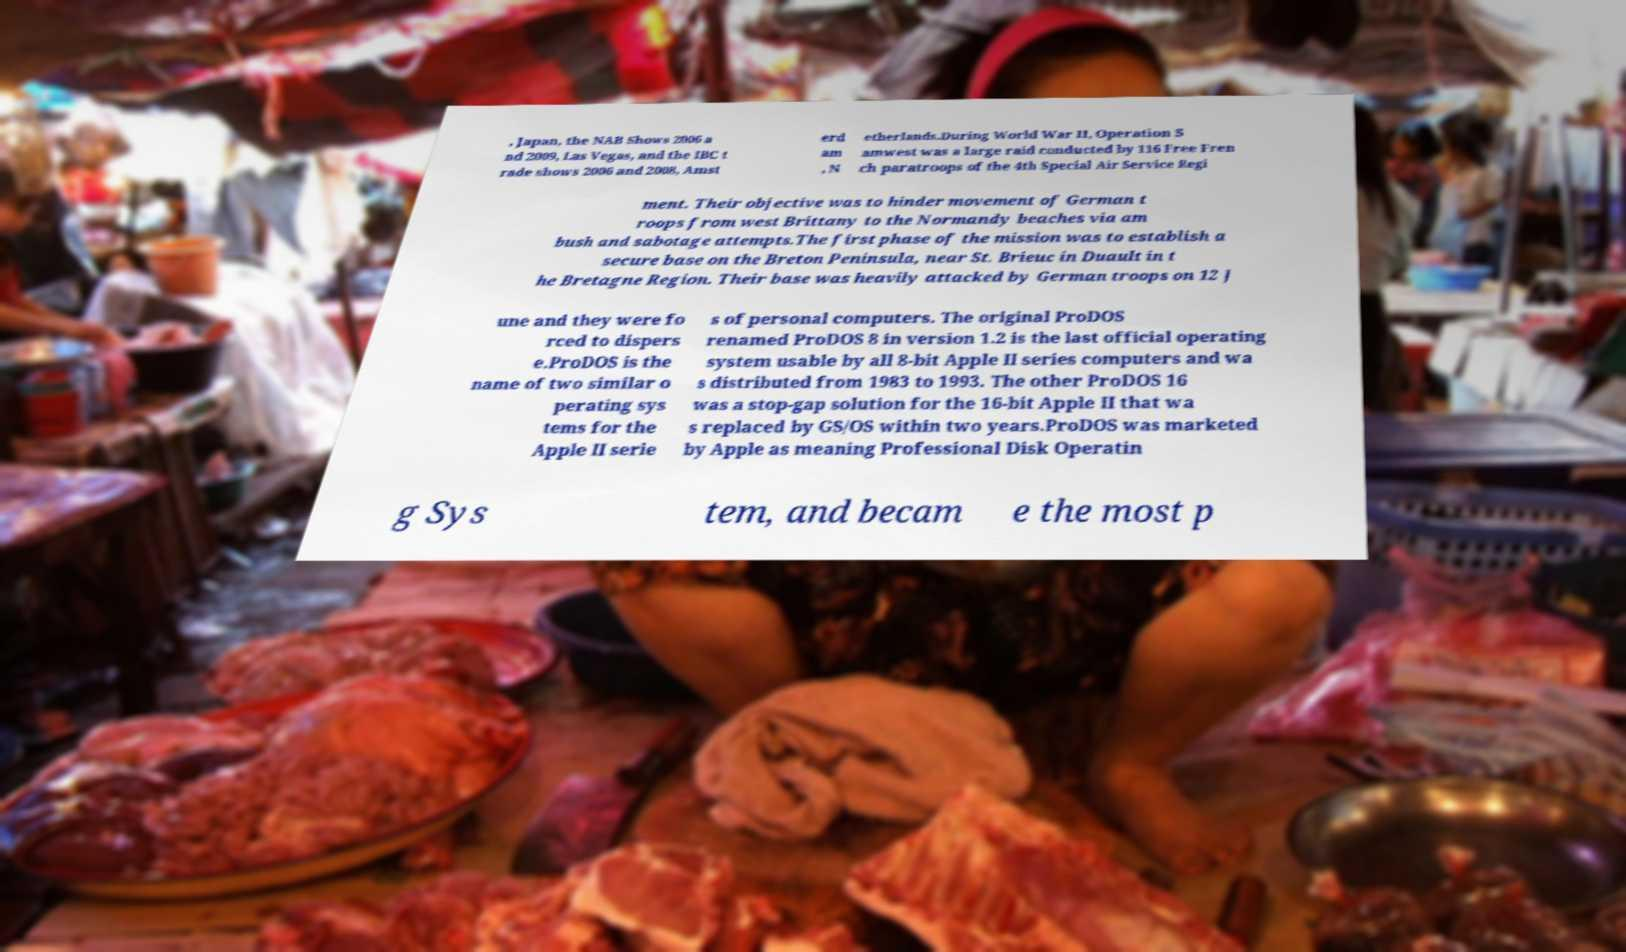I need the written content from this picture converted into text. Can you do that? , Japan, the NAB Shows 2006 a nd 2009, Las Vegas, and the IBC t rade shows 2006 and 2008, Amst erd am , N etherlands.During World War II, Operation S amwest was a large raid conducted by 116 Free Fren ch paratroops of the 4th Special Air Service Regi ment. Their objective was to hinder movement of German t roops from west Brittany to the Normandy beaches via am bush and sabotage attempts.The first phase of the mission was to establish a secure base on the Breton Peninsula, near St. Brieuc in Duault in t he Bretagne Region. Their base was heavily attacked by German troops on 12 J une and they were fo rced to dispers e.ProDOS is the name of two similar o perating sys tems for the Apple II serie s of personal computers. The original ProDOS renamed ProDOS 8 in version 1.2 is the last official operating system usable by all 8-bit Apple II series computers and wa s distributed from 1983 to 1993. The other ProDOS 16 was a stop-gap solution for the 16-bit Apple II that wa s replaced by GS/OS within two years.ProDOS was marketed by Apple as meaning Professional Disk Operatin g Sys tem, and becam e the most p 